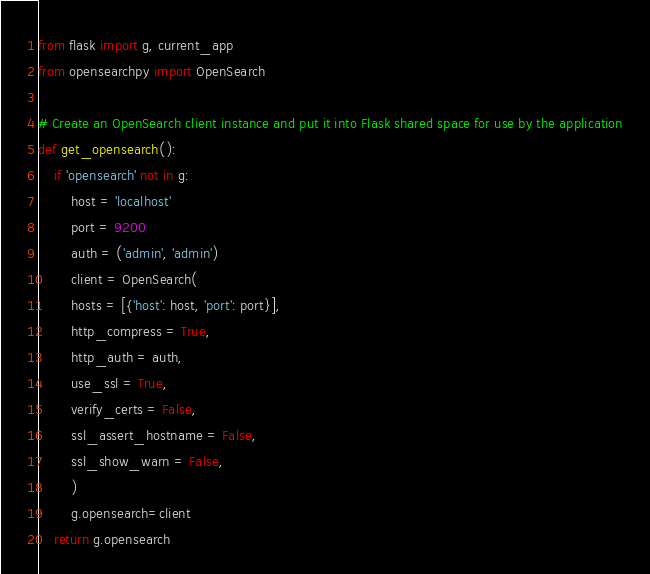Convert code to text. <code><loc_0><loc_0><loc_500><loc_500><_Python_>from flask import g, current_app
from opensearchpy import OpenSearch

# Create an OpenSearch client instance and put it into Flask shared space for use by the application
def get_opensearch():
    if 'opensearch' not in g:
        host = 'localhost'
        port = 9200
        auth = ('admin', 'admin') 
        client = OpenSearch(
        hosts = [{'host': host, 'port': port}],
        http_compress = True, 
        http_auth = auth,
        use_ssl = True,
        verify_certs = False,
        ssl_assert_hostname = False,
        ssl_show_warn = False,
        )
        g.opensearch=client 
    return g.opensearch
</code> 